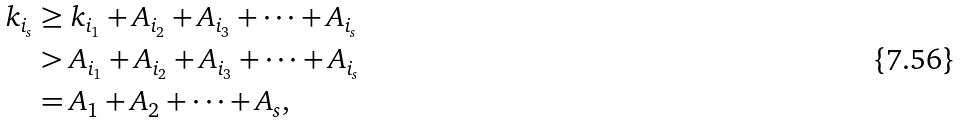Convert formula to latex. <formula><loc_0><loc_0><loc_500><loc_500>k _ { i _ { s } } & \geq k _ { i _ { 1 } } + A _ { i _ { 2 } } + A _ { i _ { 3 } } + \cdots + A _ { i _ { s } } \\ & > A _ { i _ { 1 } } + A _ { i _ { 2 } } + A _ { i _ { 3 } } + \cdots + A _ { i _ { s } } \\ & = A _ { 1 } + A _ { 2 } + \cdots + A _ { s } ,</formula> 